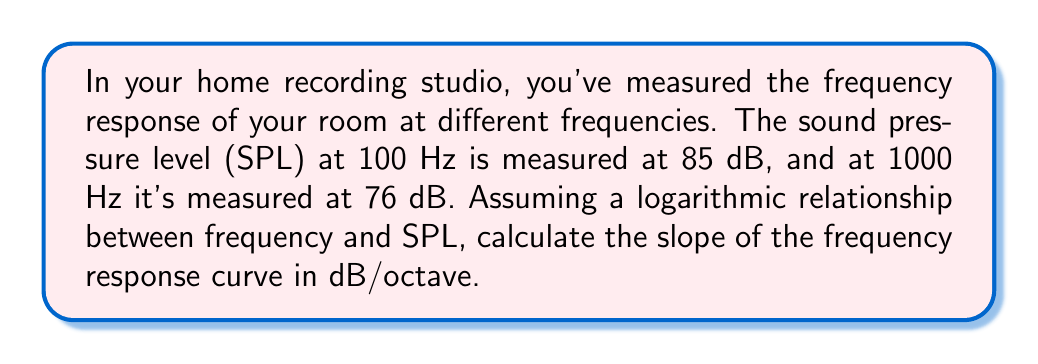Solve this math problem. To solve this problem, we need to understand the relationship between frequency and SPL on a logarithmic scale. Let's break it down step-by-step:

1) First, we need to calculate the change in SPL:
   $\Delta SPL = 76\text{ dB} - 85\text{ dB} = -9\text{ dB}$

2) Next, we need to determine the number of octaves between 100 Hz and 1000 Hz:
   An octave is a doubling of frequency. To find the number of octaves, we use the formula:
   $\text{Number of octaves} = \log_2(\frac{f_2}{f_1})$
   
   Where $f_2$ is the higher frequency and $f_1$ is the lower frequency.

   $\text{Number of octaves} = \log_2(\frac{1000}{100}) = \log_2(10) = 3.322$

3) Now we can calculate the slope in dB/octave:
   $\text{Slope} = \frac{\Delta SPL}{\text{Number of octaves}}$

   $\text{Slope} = \frac{-9\text{ dB}}{3.322\text{ octaves}} = -2.71\text{ dB/octave}$

The negative slope indicates that the SPL is decreasing as frequency increases, which is common in many recording spaces due to absorption of higher frequencies by materials in the room.
Answer: $-2.71\text{ dB/octave}$ 